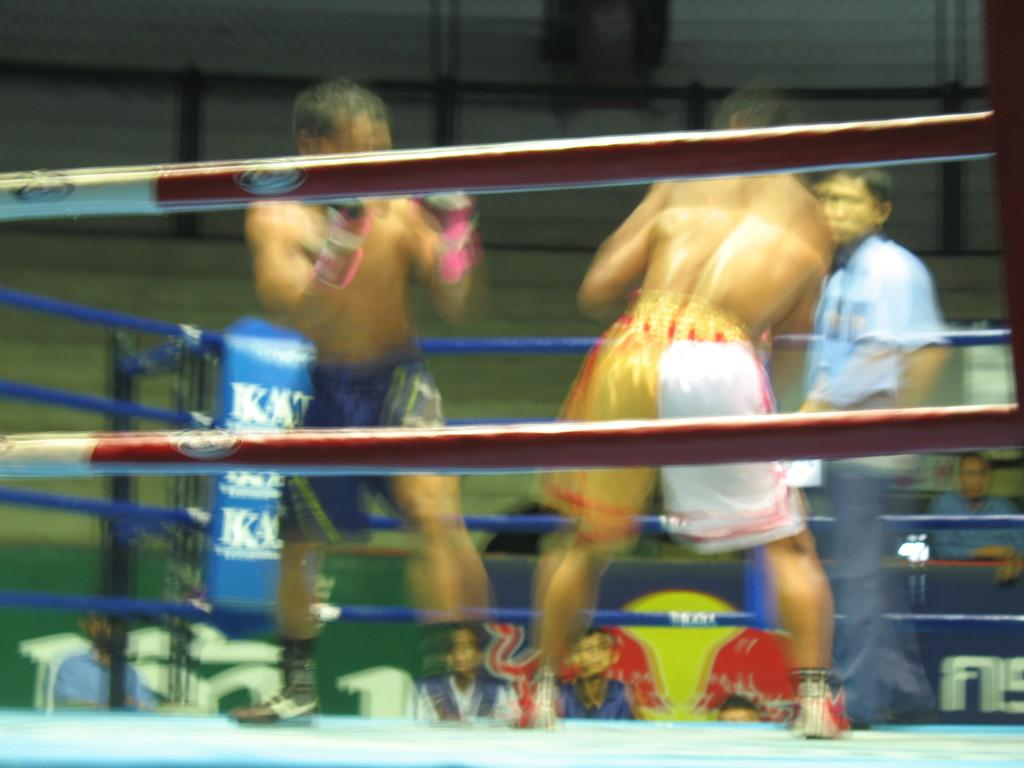What is the overall quality of the image? The image is blurry. Can you describe the subjects in the image? There is a group of people in the image. What color is present at the bottom of the image? There is blue color at the bottom of the image. What objects can be seen in the image related to ropes and poles? There are ropes and poles in the image. What type of copper object is visible in the image? There is no copper object present in the image. What historical event is depicted in the image? The image does not depict any specific historical event. 